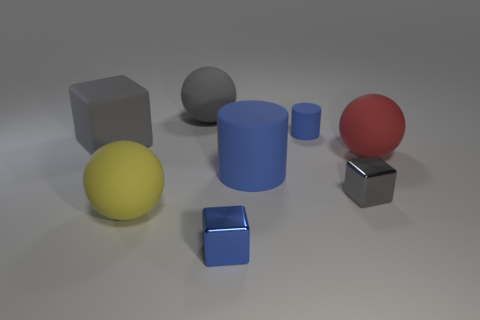The cube that is made of the same material as the large red object is what size? The cube sharing the same material characteristics as the large red sphere appears to be smaller in size, contrasting with the largeness of the sphere. 